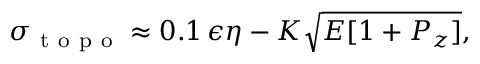<formula> <loc_0><loc_0><loc_500><loc_500>\sigma _ { t o p o } \approx 0 . 1 \, \epsilon \eta - K \sqrt { E [ 1 + P _ { z } ] } ,</formula> 